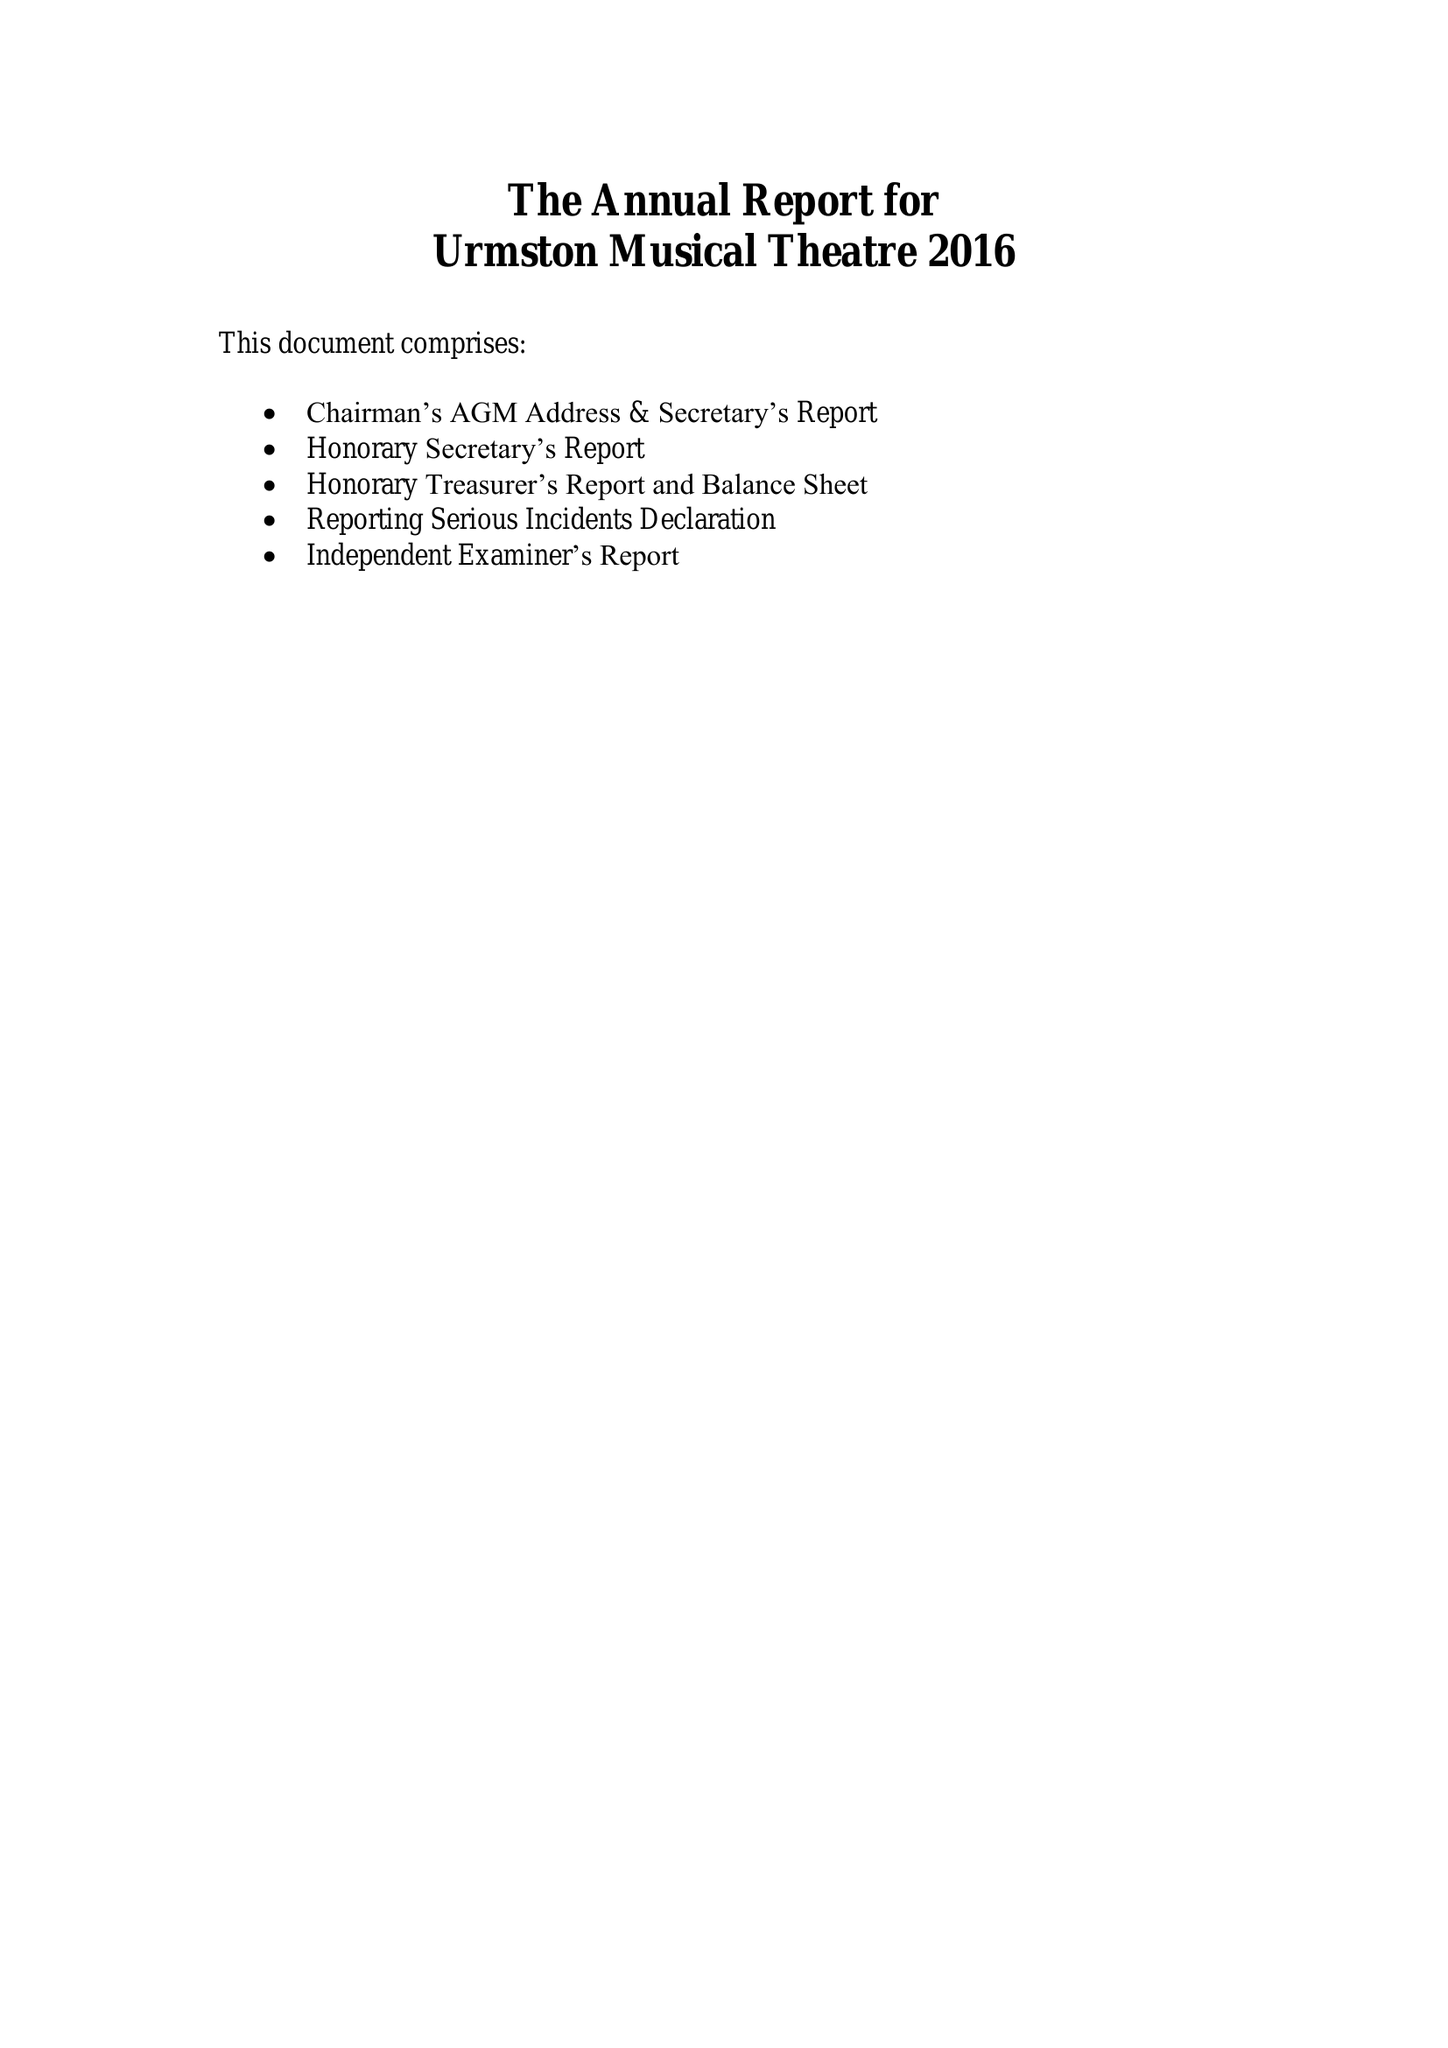What is the value for the report_date?
Answer the question using a single word or phrase. 2016-12-31 